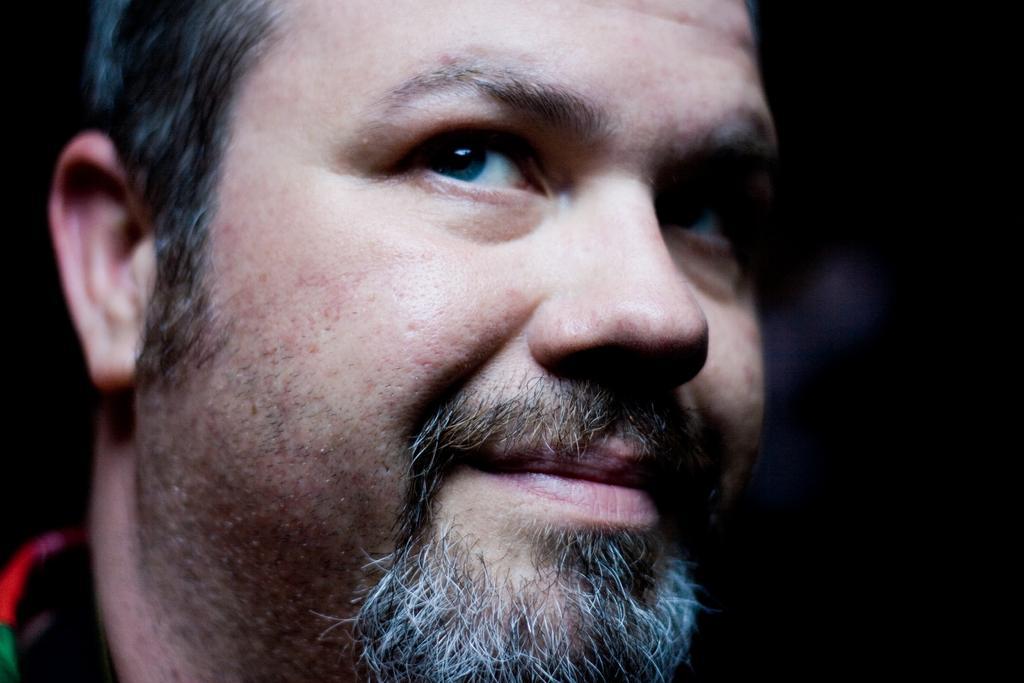How would you summarize this image in a sentence or two? In this picture there is a man. The background is blurred. 